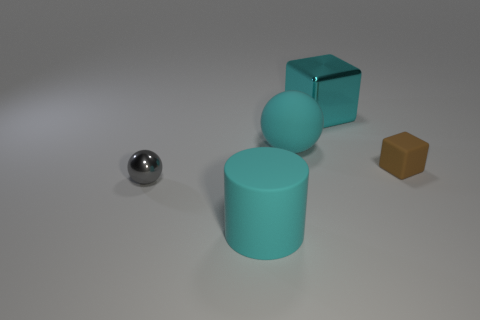Are there any small brown cylinders?
Your answer should be compact. No. Do the metal thing that is behind the brown rubber cube and the cyan matte thing that is behind the large cyan rubber cylinder have the same size?
Provide a short and direct response. Yes. There is a thing that is left of the rubber block and right of the big cyan sphere; what is its material?
Ensure brevity in your answer.  Metal. How many things are to the left of the tiny brown cube?
Your response must be concise. 4. What color is the cylinder that is the same material as the small brown object?
Your answer should be very brief. Cyan. Is the shape of the tiny rubber thing the same as the big cyan shiny object?
Make the answer very short. Yes. How many cyan objects are behind the tiny brown object and on the left side of the cyan metal thing?
Make the answer very short. 1. What number of matte objects are either large objects or tiny yellow balls?
Your response must be concise. 2. There is a cyan object in front of the metal object in front of the cyan cube; what size is it?
Provide a short and direct response. Large. What material is the large sphere that is the same color as the metal block?
Keep it short and to the point. Rubber. 